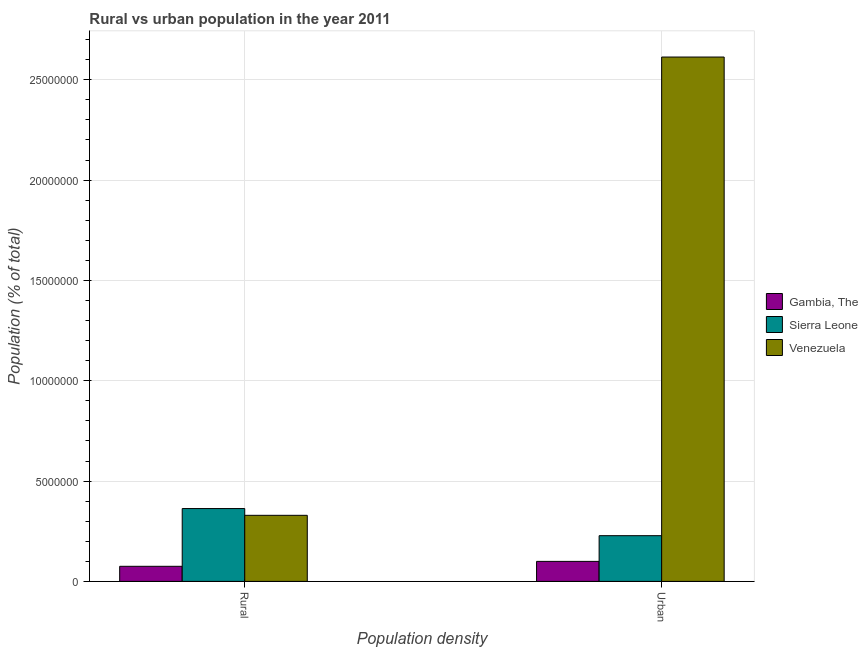How many different coloured bars are there?
Your answer should be very brief. 3. How many groups of bars are there?
Ensure brevity in your answer.  2. Are the number of bars on each tick of the X-axis equal?
Make the answer very short. Yes. What is the label of the 1st group of bars from the left?
Provide a short and direct response. Rural. What is the urban population density in Gambia, The?
Provide a short and direct response. 9.97e+05. Across all countries, what is the maximum urban population density?
Offer a very short reply. 2.61e+07. Across all countries, what is the minimum rural population density?
Keep it short and to the point. 7.52e+05. In which country was the rural population density maximum?
Offer a very short reply. Sierra Leone. In which country was the rural population density minimum?
Provide a succinct answer. Gambia, The. What is the total rural population density in the graph?
Provide a short and direct response. 7.68e+06. What is the difference between the urban population density in Sierra Leone and that in Venezuela?
Your response must be concise. -2.39e+07. What is the difference between the urban population density in Venezuela and the rural population density in Sierra Leone?
Offer a very short reply. 2.25e+07. What is the average urban population density per country?
Provide a short and direct response. 9.80e+06. What is the difference between the rural population density and urban population density in Venezuela?
Provide a short and direct response. -2.28e+07. What is the ratio of the rural population density in Venezuela to that in Gambia, The?
Offer a terse response. 4.38. Is the rural population density in Venezuela less than that in Gambia, The?
Offer a very short reply. No. What does the 1st bar from the left in Urban represents?
Give a very brief answer. Gambia, The. What does the 3rd bar from the right in Rural represents?
Offer a very short reply. Gambia, The. How many bars are there?
Your answer should be compact. 6. What is the difference between two consecutive major ticks on the Y-axis?
Give a very brief answer. 5.00e+06. Are the values on the major ticks of Y-axis written in scientific E-notation?
Keep it short and to the point. No. Does the graph contain grids?
Give a very brief answer. Yes. Where does the legend appear in the graph?
Offer a very short reply. Center right. How many legend labels are there?
Keep it short and to the point. 3. How are the legend labels stacked?
Ensure brevity in your answer.  Vertical. What is the title of the graph?
Provide a succinct answer. Rural vs urban population in the year 2011. Does "Jordan" appear as one of the legend labels in the graph?
Provide a succinct answer. No. What is the label or title of the X-axis?
Make the answer very short. Population density. What is the label or title of the Y-axis?
Offer a terse response. Population (% of total). What is the Population (% of total) in Gambia, The in Rural?
Your answer should be compact. 7.52e+05. What is the Population (% of total) in Sierra Leone in Rural?
Give a very brief answer. 3.63e+06. What is the Population (% of total) in Venezuela in Rural?
Keep it short and to the point. 3.29e+06. What is the Population (% of total) in Gambia, The in Urban?
Your answer should be compact. 9.97e+05. What is the Population (% of total) in Sierra Leone in Urban?
Offer a very short reply. 2.28e+06. What is the Population (% of total) in Venezuela in Urban?
Provide a succinct answer. 2.61e+07. Across all Population density, what is the maximum Population (% of total) of Gambia, The?
Provide a short and direct response. 9.97e+05. Across all Population density, what is the maximum Population (% of total) of Sierra Leone?
Give a very brief answer. 3.63e+06. Across all Population density, what is the maximum Population (% of total) of Venezuela?
Your response must be concise. 2.61e+07. Across all Population density, what is the minimum Population (% of total) of Gambia, The?
Your answer should be compact. 7.52e+05. Across all Population density, what is the minimum Population (% of total) in Sierra Leone?
Your answer should be compact. 2.28e+06. Across all Population density, what is the minimum Population (% of total) in Venezuela?
Your response must be concise. 3.29e+06. What is the total Population (% of total) of Gambia, The in the graph?
Provide a short and direct response. 1.75e+06. What is the total Population (% of total) in Sierra Leone in the graph?
Provide a short and direct response. 5.91e+06. What is the total Population (% of total) of Venezuela in the graph?
Your answer should be compact. 2.94e+07. What is the difference between the Population (% of total) of Gambia, The in Rural and that in Urban?
Offer a terse response. -2.45e+05. What is the difference between the Population (% of total) of Sierra Leone in Rural and that in Urban?
Your answer should be very brief. 1.35e+06. What is the difference between the Population (% of total) in Venezuela in Rural and that in Urban?
Keep it short and to the point. -2.28e+07. What is the difference between the Population (% of total) in Gambia, The in Rural and the Population (% of total) in Sierra Leone in Urban?
Provide a succinct answer. -1.53e+06. What is the difference between the Population (% of total) of Gambia, The in Rural and the Population (% of total) of Venezuela in Urban?
Make the answer very short. -2.54e+07. What is the difference between the Population (% of total) in Sierra Leone in Rural and the Population (% of total) in Venezuela in Urban?
Offer a terse response. -2.25e+07. What is the average Population (% of total) of Gambia, The per Population density?
Provide a short and direct response. 8.75e+05. What is the average Population (% of total) of Sierra Leone per Population density?
Your answer should be very brief. 2.95e+06. What is the average Population (% of total) in Venezuela per Population density?
Make the answer very short. 1.47e+07. What is the difference between the Population (% of total) in Gambia, The and Population (% of total) in Sierra Leone in Rural?
Your answer should be compact. -2.88e+06. What is the difference between the Population (% of total) in Gambia, The and Population (% of total) in Venezuela in Rural?
Make the answer very short. -2.54e+06. What is the difference between the Population (% of total) in Sierra Leone and Population (% of total) in Venezuela in Rural?
Give a very brief answer. 3.38e+05. What is the difference between the Population (% of total) in Gambia, The and Population (% of total) in Sierra Leone in Urban?
Offer a terse response. -1.28e+06. What is the difference between the Population (% of total) in Gambia, The and Population (% of total) in Venezuela in Urban?
Your answer should be compact. -2.51e+07. What is the difference between the Population (% of total) of Sierra Leone and Population (% of total) of Venezuela in Urban?
Give a very brief answer. -2.39e+07. What is the ratio of the Population (% of total) of Gambia, The in Rural to that in Urban?
Your response must be concise. 0.75. What is the ratio of the Population (% of total) of Sierra Leone in Rural to that in Urban?
Your answer should be compact. 1.59. What is the ratio of the Population (% of total) of Venezuela in Rural to that in Urban?
Your answer should be very brief. 0.13. What is the difference between the highest and the second highest Population (% of total) of Gambia, The?
Your answer should be compact. 2.45e+05. What is the difference between the highest and the second highest Population (% of total) of Sierra Leone?
Offer a terse response. 1.35e+06. What is the difference between the highest and the second highest Population (% of total) in Venezuela?
Ensure brevity in your answer.  2.28e+07. What is the difference between the highest and the lowest Population (% of total) in Gambia, The?
Your answer should be compact. 2.45e+05. What is the difference between the highest and the lowest Population (% of total) of Sierra Leone?
Your answer should be compact. 1.35e+06. What is the difference between the highest and the lowest Population (% of total) in Venezuela?
Provide a succinct answer. 2.28e+07. 